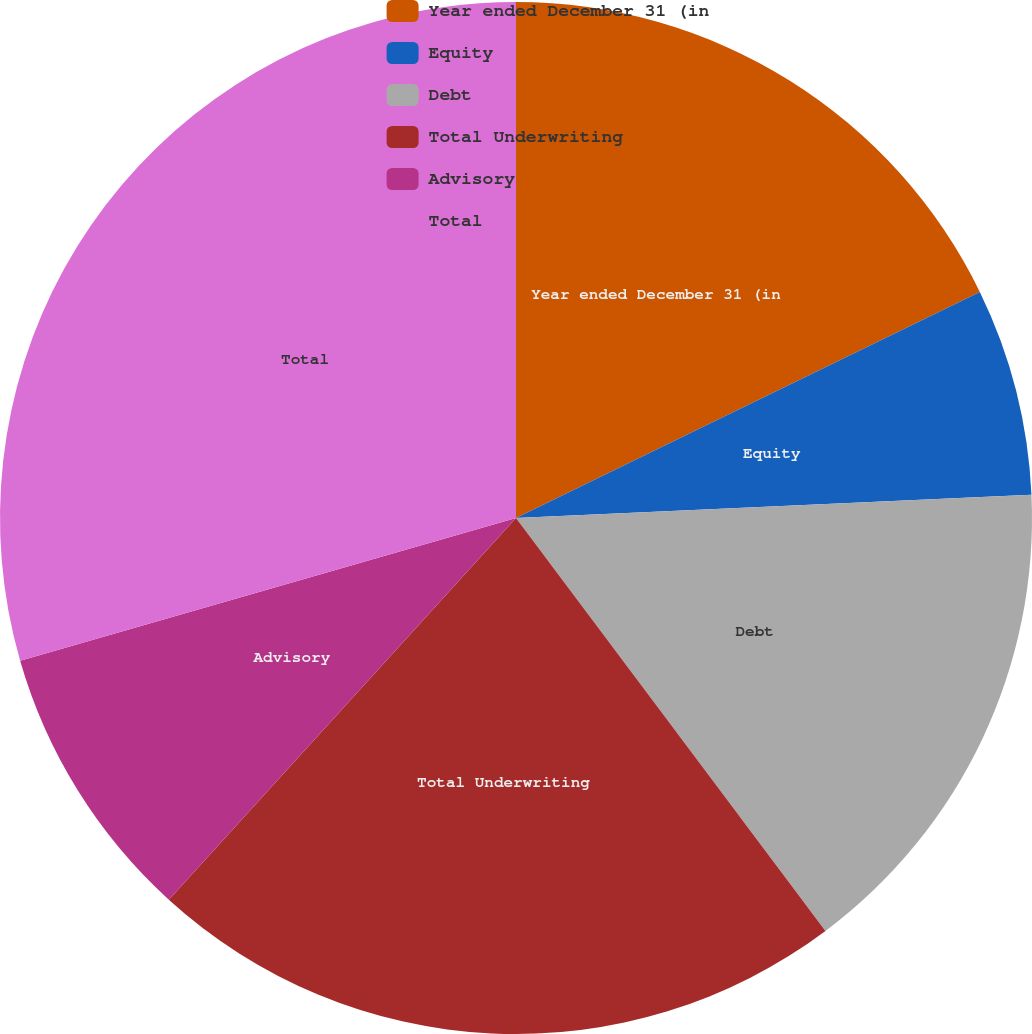Convert chart to OTSL. <chart><loc_0><loc_0><loc_500><loc_500><pie_chart><fcel>Year ended December 31 (in<fcel>Equity<fcel>Debt<fcel>Total Underwriting<fcel>Advisory<fcel>Total<nl><fcel>17.78%<fcel>6.5%<fcel>15.48%<fcel>21.98%<fcel>8.79%<fcel>29.46%<nl></chart> 